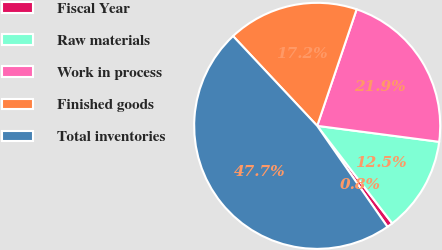<chart> <loc_0><loc_0><loc_500><loc_500><pie_chart><fcel>Fiscal Year<fcel>Raw materials<fcel>Work in process<fcel>Finished goods<fcel>Total inventories<nl><fcel>0.76%<fcel>12.49%<fcel>21.88%<fcel>17.18%<fcel>47.69%<nl></chart> 